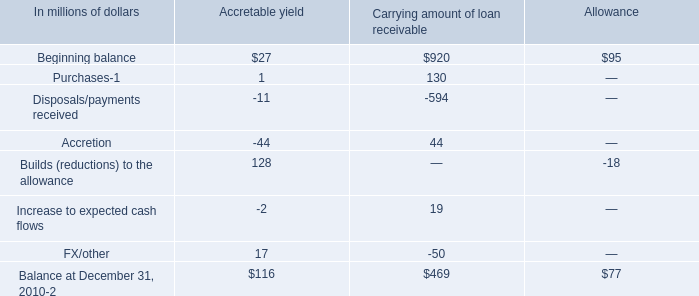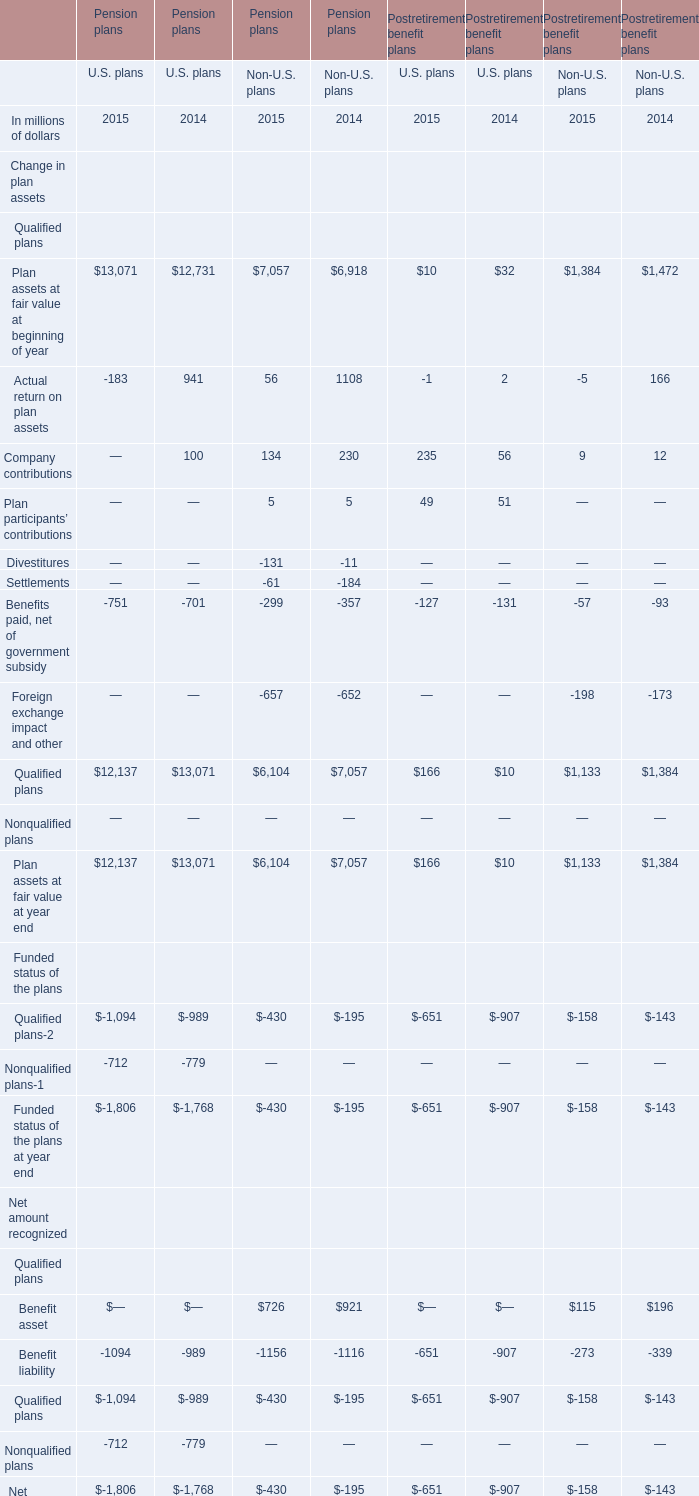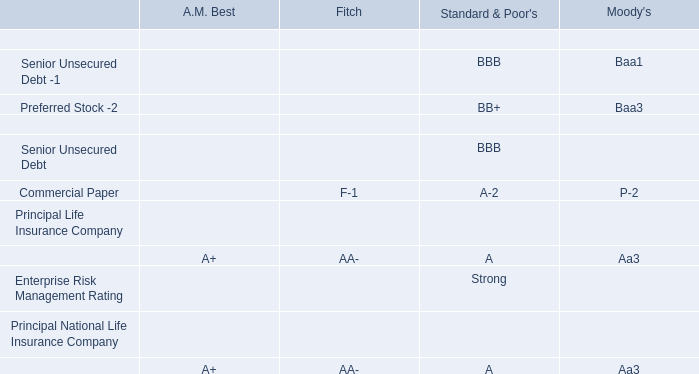Which year is Plan assets at fair value at beginning of year in U.S. Pension plans the most? 
Answer: 2015. 